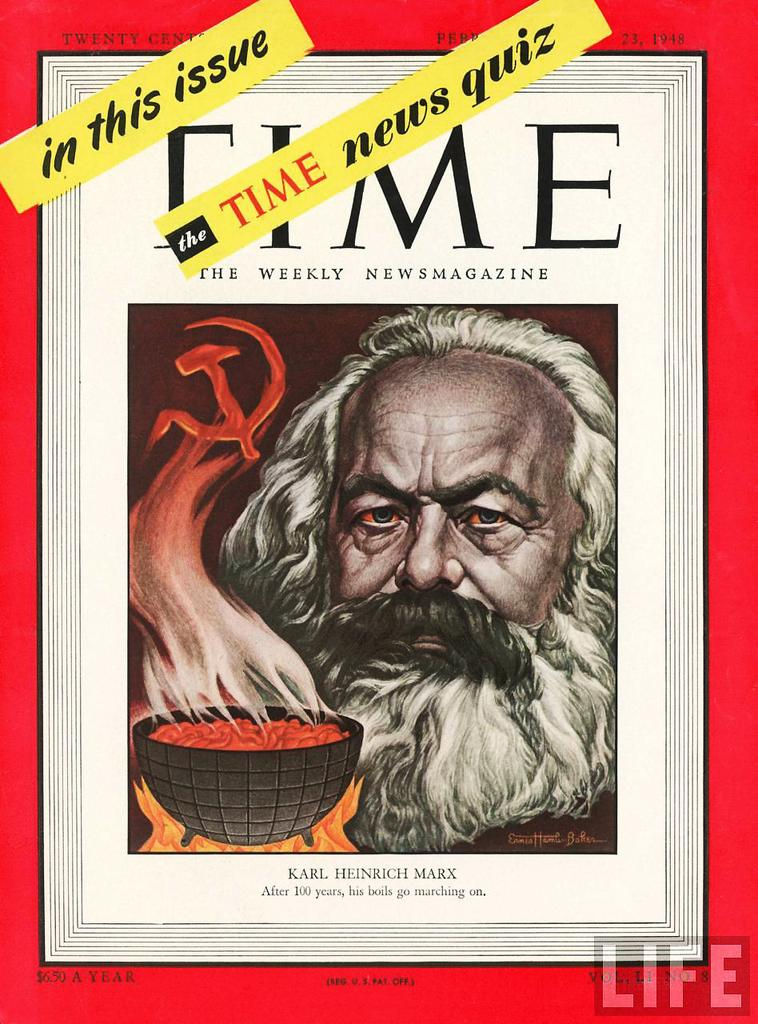Provide a one-sentence caption for the provided image. Time the weekly newsmagazine by Karl Heinrich Marx. 